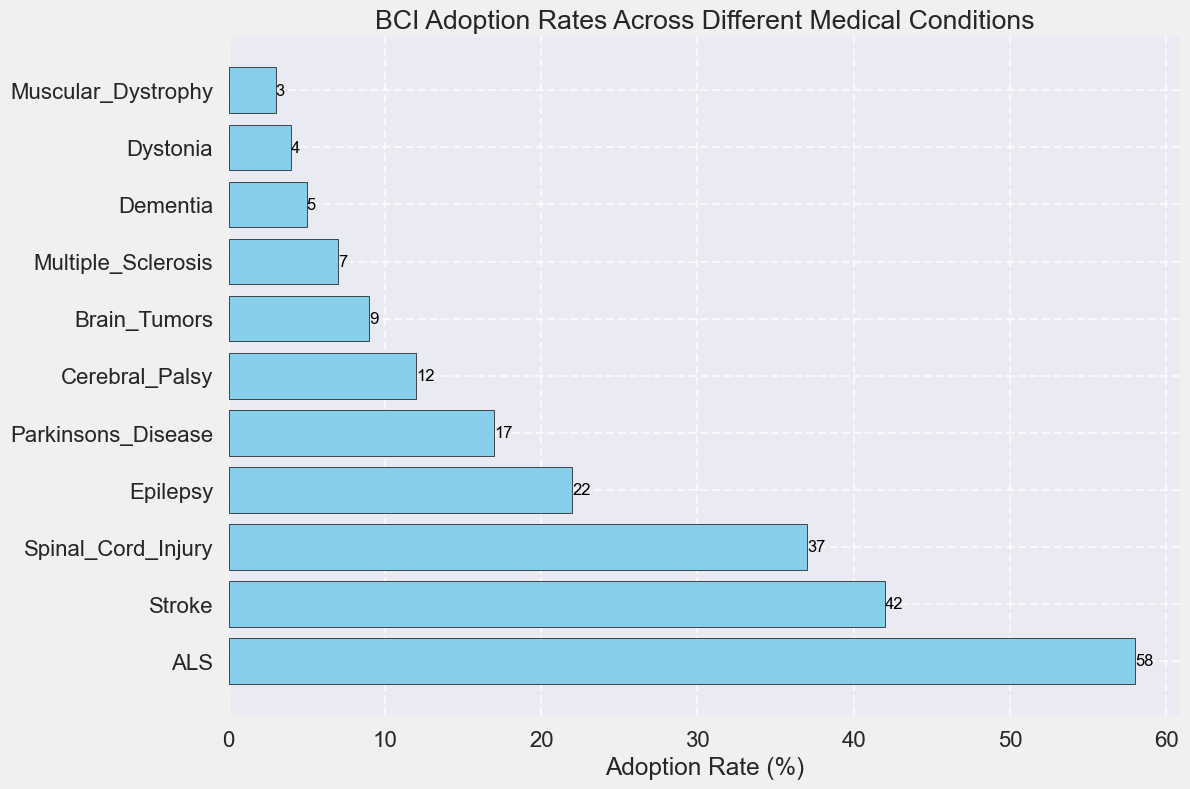What condition has the highest BCI adoption rate? The condition with the highest bar represents the highest BCI adoption rate. Here, ALS has the highest bar reaching 58%.
Answer: ALS Which condition has a lower adoption rate, Epilepsy or Parkinson's Disease? Comparing the heights of the bars for Epilepsy and Parkinson's Disease, Epilepsy has an adoption rate of 22% while Parkinson's Disease has an adoption rate of 17%.
Answer: Parkinson's Disease What's the total adoption rate for Spinal Cord Injury, Brain Tumors, and Muscular Dystrophy? Adding the adoption rates for each: 37% (Spinal Cord Injury) + 9% (Brain Tumors) + 3% (Muscular Dystrophy) = 49%.
Answer: 49% How does the adoption rate of Multiple Sclerosis compare to Dementia? The heights of the bars indicate that Multiple Sclerosis has an adoption rate of 7%, and Dementia has an adoption rate of 5%. Therefore, Multiple Sclerosis has a higher adoption rate.
Answer: Multiple Sclerosis What is the median adoption rate among all conditions? To find the median, we first list the adoption rates in order: 3, 4, 5, 7, 9, 12, 17, 22, 37, 42, 58. The middle value in this ordered list is 12, which is the rate for Cerebral Palsy.
Answer: 12 Which condition exhibits the least BCI adoption rate? The condition with the shortest bar represents the least adoption rate. Here, Muscular Dystrophy has the shortest bar, indicating 3%.
Answer: Muscular Dystrophy By how much does the adoption rate for ALS exceed the rate for Epilepsy? Subtract the adoption rate of Epilepsy from that of ALS: 58% - 22% = 36%.
Answer: 36% Which condition's adoption rate is closest to the average adoption rate of all conditions? First, calculate the sum of all adoption rates: 58 + 42 + 37 + 22 + 17 + 12 + 9 + 7 + 5 + 4 + 3 = 216. The average rate is 216/11 ≈ 19.64. The rate closest to this is Parkinson's Disease with 17%.
Answer: Parkinson's Disease What percentage of the conditions have an adoption rate below 10%? Count the number of conditions with adoption rates below 10% (Brain Tumors, Multiple Sclerosis, Dementia, Dystonia, Muscular Dystrophy = 5 conditions) and divide by the total number of conditions (11), then multiply by 100 to convert to a percentage: (5/11) * 100 ≈ 45.45%.
Answer: ~45.45% 